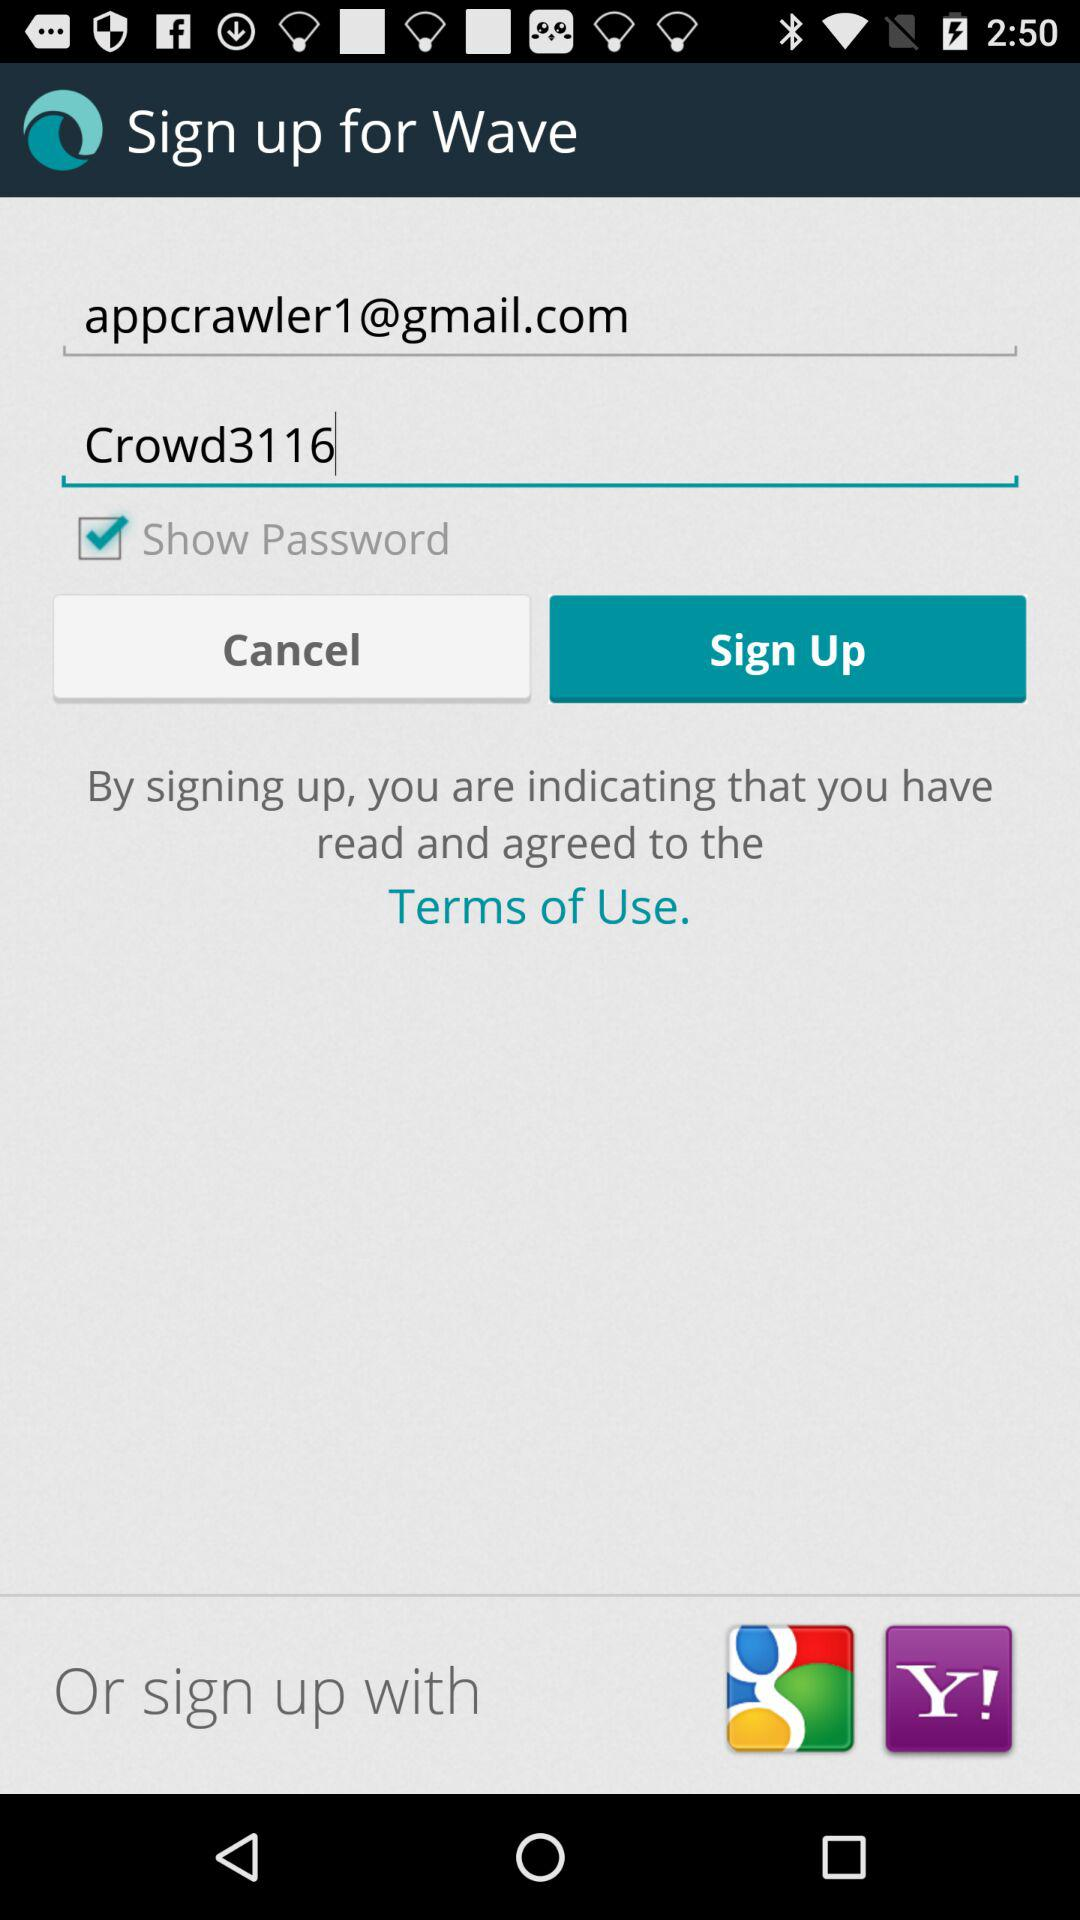What are the other sign-up options? The other sign-up options are "Google" and "Yahoo". 